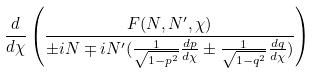<formula> <loc_0><loc_0><loc_500><loc_500>\frac { d } { d \chi } \left ( \frac { F ( N , N ^ { \prime } , \chi ) } { \pm i N \mp i N ^ { \prime } ( \frac { 1 } { \sqrt { 1 - p ^ { 2 } } } \frac { d p } { d \chi } \pm \frac { 1 } { \sqrt { 1 - q ^ { 2 } } } \frac { d q } { d \chi } ) } \right )</formula> 